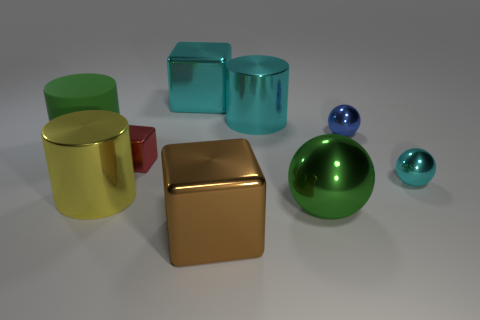Are there any other things that are the same size as the green cylinder?
Your response must be concise. Yes. What is the shape of the rubber thing that is the same color as the big sphere?
Give a very brief answer. Cylinder. Is the color of the large rubber thing the same as the large ball?
Ensure brevity in your answer.  Yes. Is there any other thing that has the same material as the green cylinder?
Provide a short and direct response. No. The big green thing to the left of the green metal object in front of the cyan shiny cylinder is what shape?
Ensure brevity in your answer.  Cylinder. What number of other things are there of the same shape as the yellow shiny object?
Your answer should be compact. 2. Are there any things right of the small cyan thing?
Make the answer very short. No. The large matte thing is what color?
Your response must be concise. Green. There is a matte thing; is its color the same as the ball that is in front of the yellow metal cylinder?
Your answer should be compact. Yes. Is there a ball that has the same size as the red block?
Provide a short and direct response. Yes. 